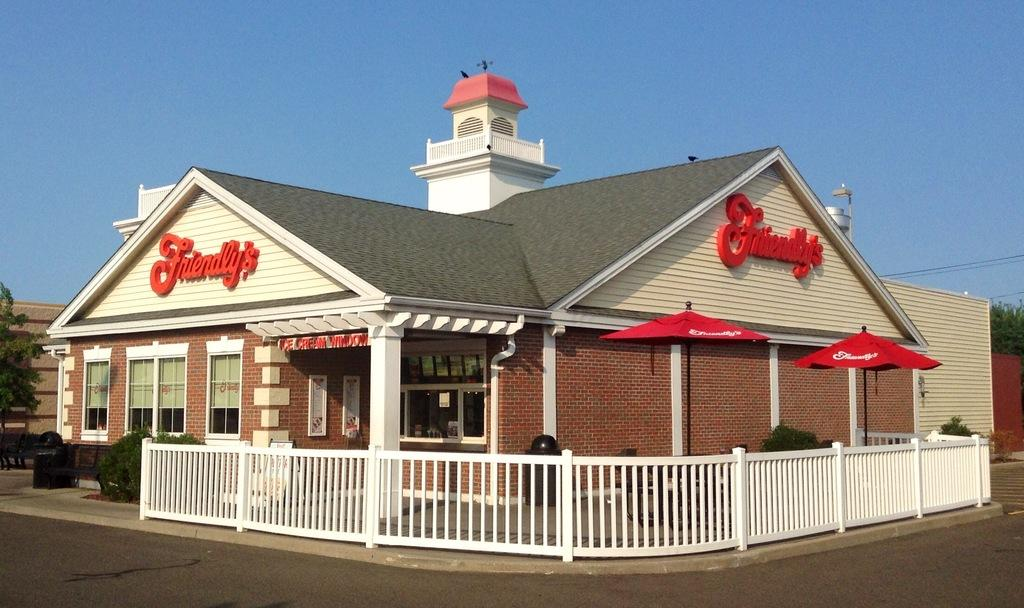<image>
Give a short and clear explanation of the subsequent image. an outside view of the restaurant Friendly's with a fence around it 